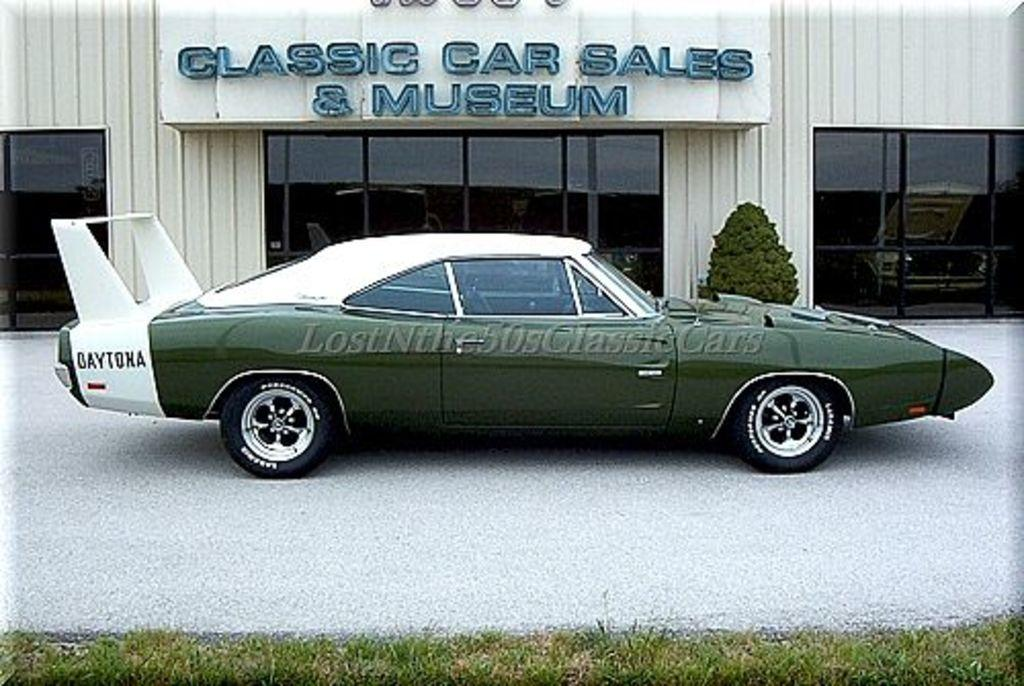What is the main subject of the image? The main subject of the image is a car. Can you describe the color of the car? The car is green and white in color. What can be seen in the background of the image? There is a building in the background of the image. Are there any other objects or living organisms in the image? Yes, there is a plant in the image. How many crates are stacked next to the car in the image? There are no crates present in the image; it only features a car, a building in the background, and a plant. 